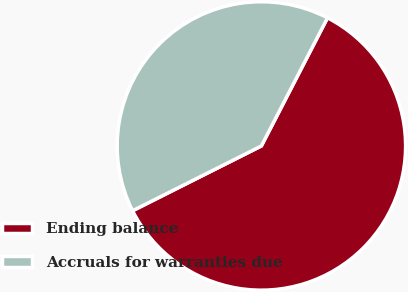Convert chart. <chart><loc_0><loc_0><loc_500><loc_500><pie_chart><fcel>Ending balance<fcel>Accruals for warranties due<nl><fcel>60.0%<fcel>40.0%<nl></chart> 